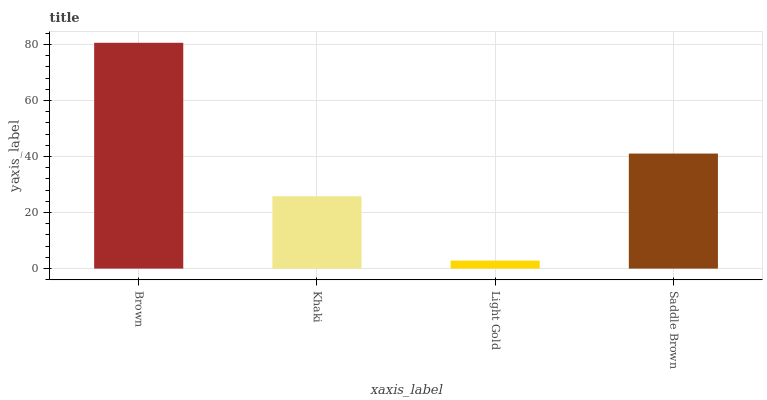Is Light Gold the minimum?
Answer yes or no. Yes. Is Brown the maximum?
Answer yes or no. Yes. Is Khaki the minimum?
Answer yes or no. No. Is Khaki the maximum?
Answer yes or no. No. Is Brown greater than Khaki?
Answer yes or no. Yes. Is Khaki less than Brown?
Answer yes or no. Yes. Is Khaki greater than Brown?
Answer yes or no. No. Is Brown less than Khaki?
Answer yes or no. No. Is Saddle Brown the high median?
Answer yes or no. Yes. Is Khaki the low median?
Answer yes or no. Yes. Is Light Gold the high median?
Answer yes or no. No. Is Saddle Brown the low median?
Answer yes or no. No. 